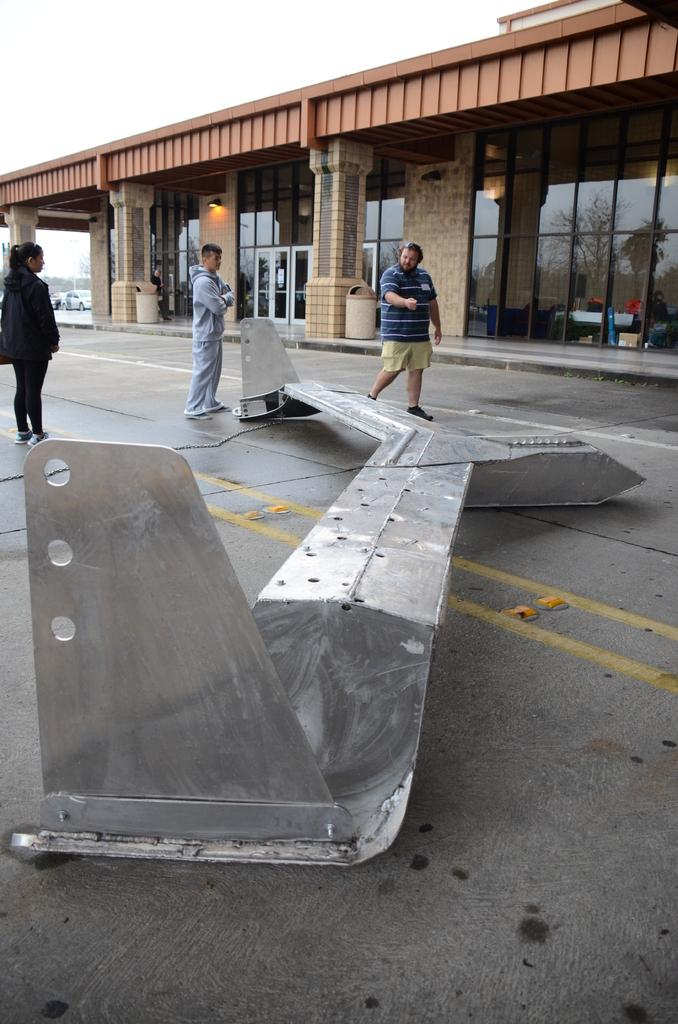How many people are in the image? There are three persons standing in the image. What is located on the road in the image? There is a metal object on the road. What can be seen in the background of the image? There is a building and vehicles in the background of the image, as well as the sky. What type of muscle is being exercised by the persons in the image? There is no indication in the image that the persons are exercising or engaging in any physical activity, so it cannot be determined which muscle, if any, they might be using. 